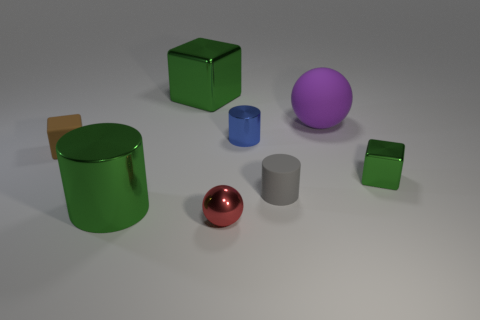Are there any gray cylinders that have the same size as the blue metallic cylinder?
Make the answer very short. Yes. Are there fewer large green metallic cubes that are behind the tiny gray matte cylinder than blue rubber balls?
Provide a short and direct response. No. Do the green metallic cylinder and the blue object have the same size?
Ensure brevity in your answer.  No. There is a red object that is made of the same material as the green cylinder; what is its size?
Offer a terse response. Small. What number of other tiny cylinders have the same color as the small metal cylinder?
Keep it short and to the point. 0. Are there fewer red metal spheres in front of the blue object than gray cylinders in front of the gray rubber cylinder?
Provide a short and direct response. No. Does the rubber object in front of the small metallic cube have the same shape as the small brown object?
Offer a very short reply. No. Is there anything else that has the same material as the brown thing?
Offer a very short reply. Yes. Are the green cube on the right side of the metal ball and the red ball made of the same material?
Keep it short and to the point. Yes. The small cube that is right of the large green object that is behind the small metal thing that is right of the big purple object is made of what material?
Provide a succinct answer. Metal. 